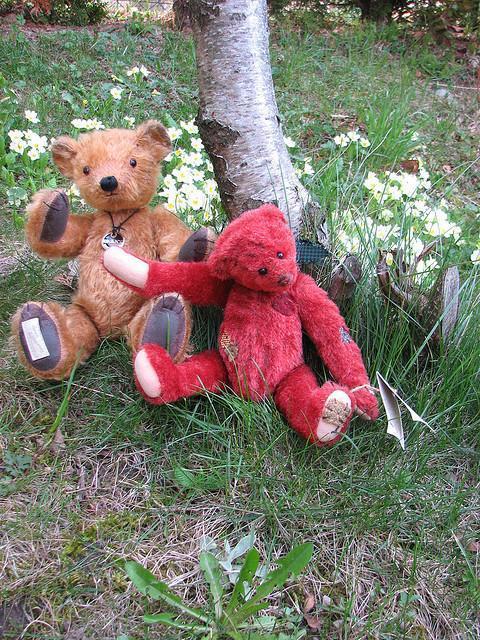How many toys are here?
Give a very brief answer. 2. How many teddy bears are there?
Give a very brief answer. 2. How many people are shown?
Give a very brief answer. 0. 